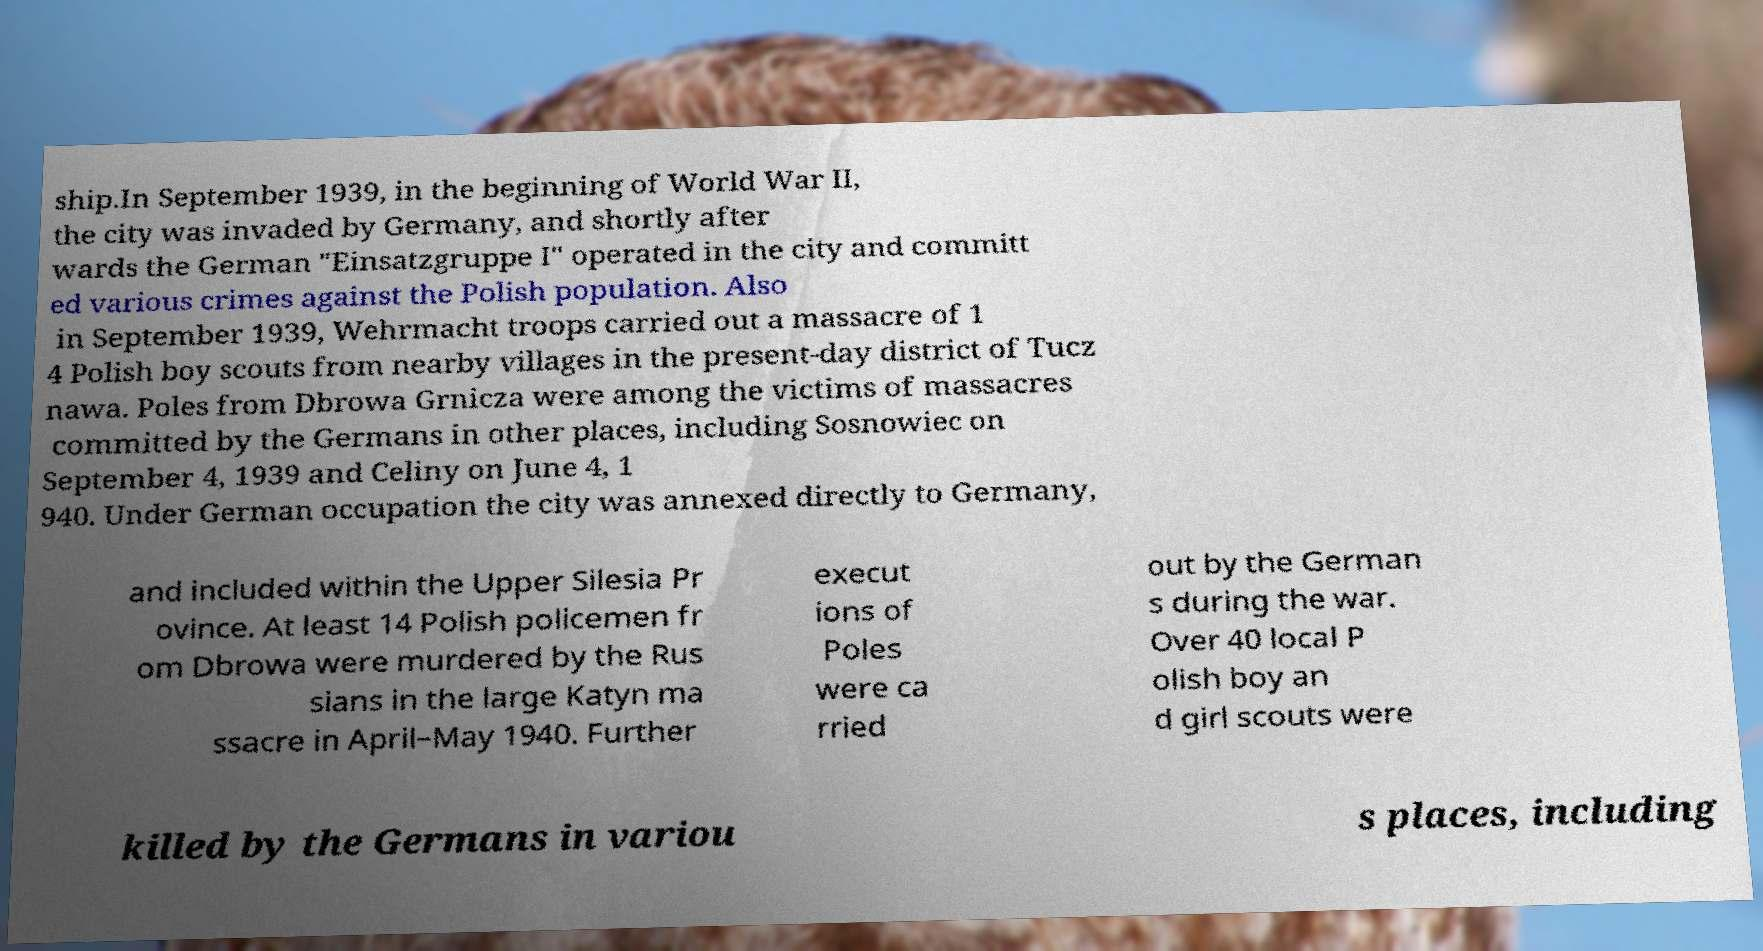I need the written content from this picture converted into text. Can you do that? ship.In September 1939, in the beginning of World War II, the city was invaded by Germany, and shortly after wards the German "Einsatzgruppe I" operated in the city and committ ed various crimes against the Polish population. Also in September 1939, Wehrmacht troops carried out a massacre of 1 4 Polish boy scouts from nearby villages in the present-day district of Tucz nawa. Poles from Dbrowa Grnicza were among the victims of massacres committed by the Germans in other places, including Sosnowiec on September 4, 1939 and Celiny on June 4, 1 940. Under German occupation the city was annexed directly to Germany, and included within the Upper Silesia Pr ovince. At least 14 Polish policemen fr om Dbrowa were murdered by the Rus sians in the large Katyn ma ssacre in April–May 1940. Further execut ions of Poles were ca rried out by the German s during the war. Over 40 local P olish boy an d girl scouts were killed by the Germans in variou s places, including 